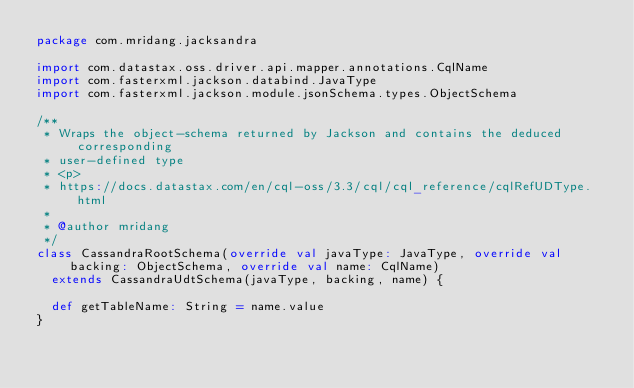<code> <loc_0><loc_0><loc_500><loc_500><_Scala_>package com.mridang.jacksandra

import com.datastax.oss.driver.api.mapper.annotations.CqlName
import com.fasterxml.jackson.databind.JavaType
import com.fasterxml.jackson.module.jsonSchema.types.ObjectSchema

/**
 * Wraps the object-schema returned by Jackson and contains the deduced corresponding
 * user-defined type
 * <p>
 * https://docs.datastax.com/en/cql-oss/3.3/cql/cql_reference/cqlRefUDType.html
 *
 * @author mridang
 */
class CassandraRootSchema(override val javaType: JavaType, override val backing: ObjectSchema, override val name: CqlName)
  extends CassandraUdtSchema(javaType, backing, name) {

  def getTableName: String = name.value
}
</code> 